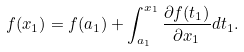<formula> <loc_0><loc_0><loc_500><loc_500>f ( x _ { 1 } ) = f ( a _ { 1 } ) + \int _ { a _ { 1 } } ^ { x _ { 1 } } \frac { \partial f ( t _ { 1 } ) } { \partial x _ { 1 } } d t _ { 1 } .</formula> 